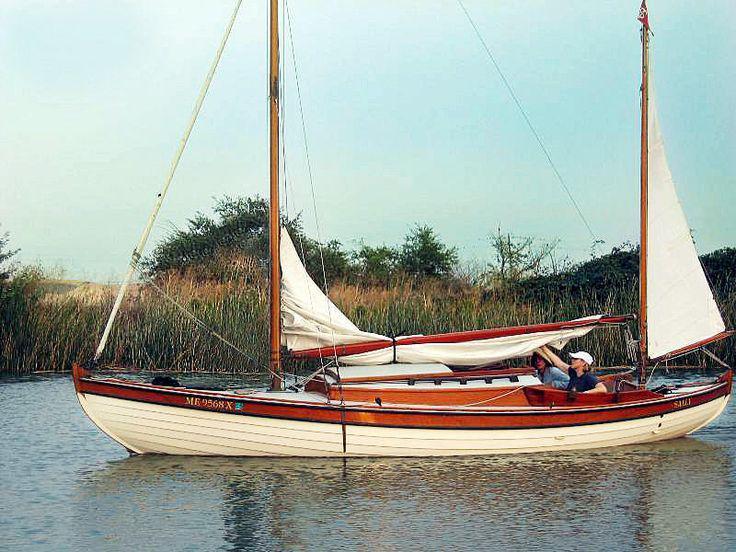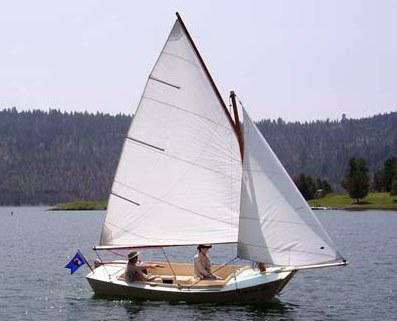The first image is the image on the left, the second image is the image on the right. Examine the images to the left and right. Is the description "An image shows a white-bodied boat with only reddish sails." accurate? Answer yes or no. No. The first image is the image on the left, the second image is the image on the right. Considering the images on both sides, is "The sails on both boats are nearly the same color." valid? Answer yes or no. Yes. 